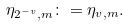<formula> <loc_0><loc_0><loc_500><loc_500>\eta _ { 2 ^ { - v } , m } \colon = \eta _ { v , m } .</formula> 